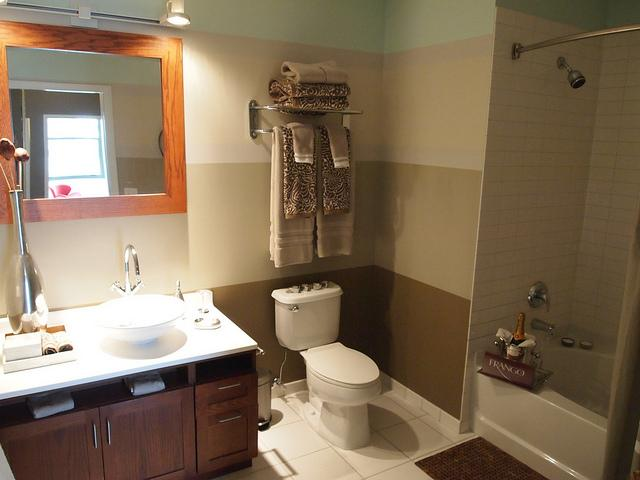What is on the rack sitting on the bathtub's edge? Please explain your reasoning. wine. There is a glass bottle on the bathtub's edge. it contains alcohol, not soap, shampoo, or conditioner. 